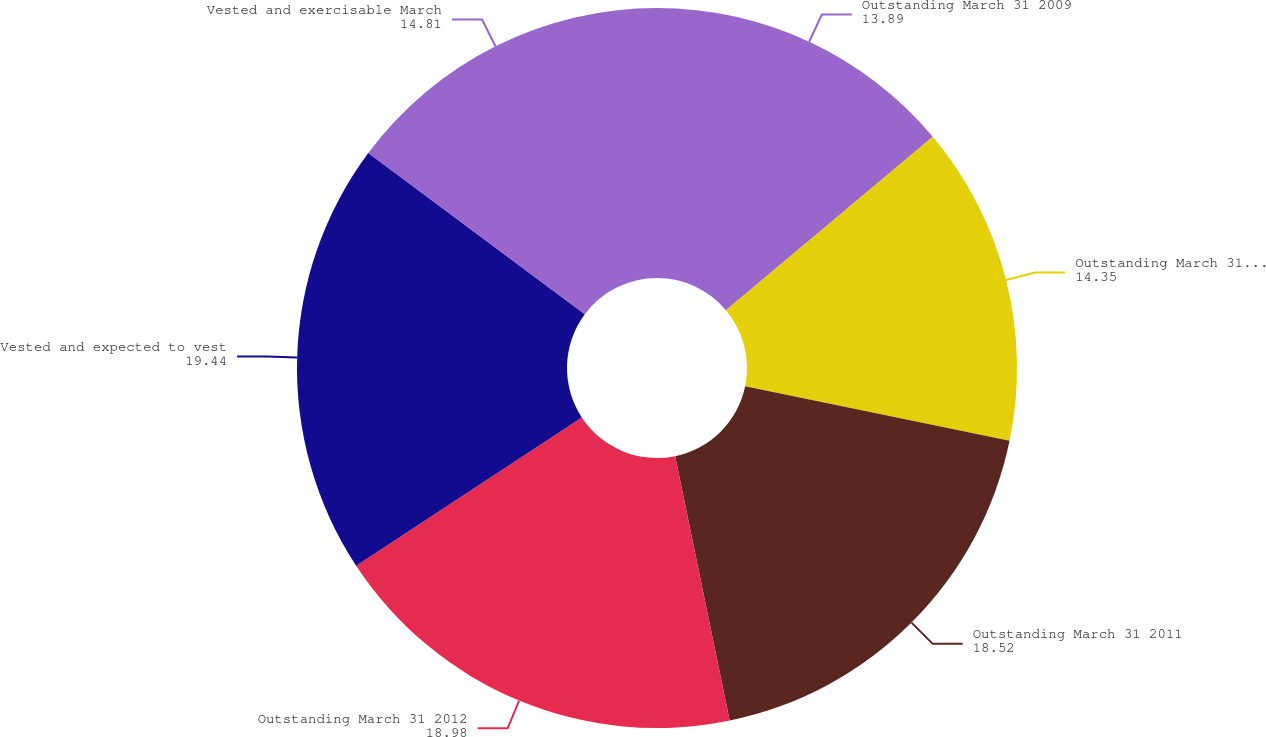Convert chart to OTSL. <chart><loc_0><loc_0><loc_500><loc_500><pie_chart><fcel>Outstanding March 31 2009<fcel>Outstanding March 31 2010<fcel>Outstanding March 31 2011<fcel>Outstanding March 31 2012<fcel>Vested and expected to vest<fcel>Vested and exercisable March<nl><fcel>13.89%<fcel>14.35%<fcel>18.52%<fcel>18.98%<fcel>19.44%<fcel>14.81%<nl></chart> 